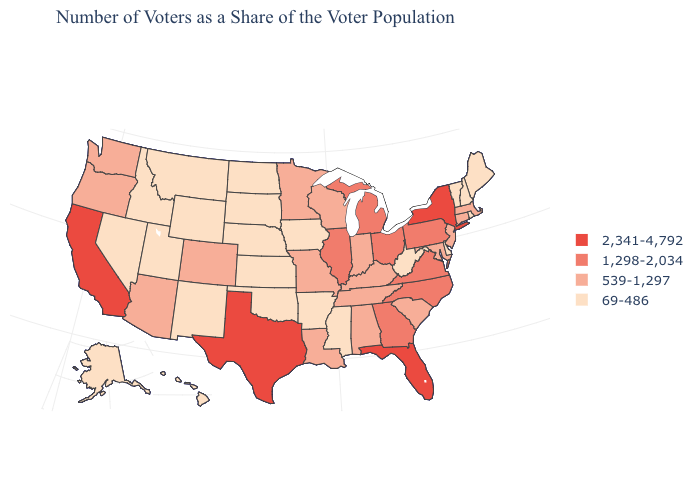Which states have the highest value in the USA?
Give a very brief answer. California, Florida, New York, Texas. How many symbols are there in the legend?
Short answer required. 4. Which states have the highest value in the USA?
Keep it brief. California, Florida, New York, Texas. Does Texas have the highest value in the USA?
Short answer required. Yes. What is the lowest value in the USA?
Quick response, please. 69-486. Does Oregon have the highest value in the USA?
Concise answer only. No. Among the states that border Ohio , does Michigan have the highest value?
Be succinct. Yes. What is the value of New Mexico?
Quick response, please. 69-486. Which states have the lowest value in the Northeast?
Concise answer only. Maine, New Hampshire, Rhode Island, Vermont. What is the lowest value in the MidWest?
Quick response, please. 69-486. Does New York have the lowest value in the Northeast?
Be succinct. No. Does Maine have a lower value than Kentucky?
Short answer required. Yes. Among the states that border North Carolina , which have the lowest value?
Answer briefly. South Carolina, Tennessee. What is the lowest value in the USA?
Give a very brief answer. 69-486. 